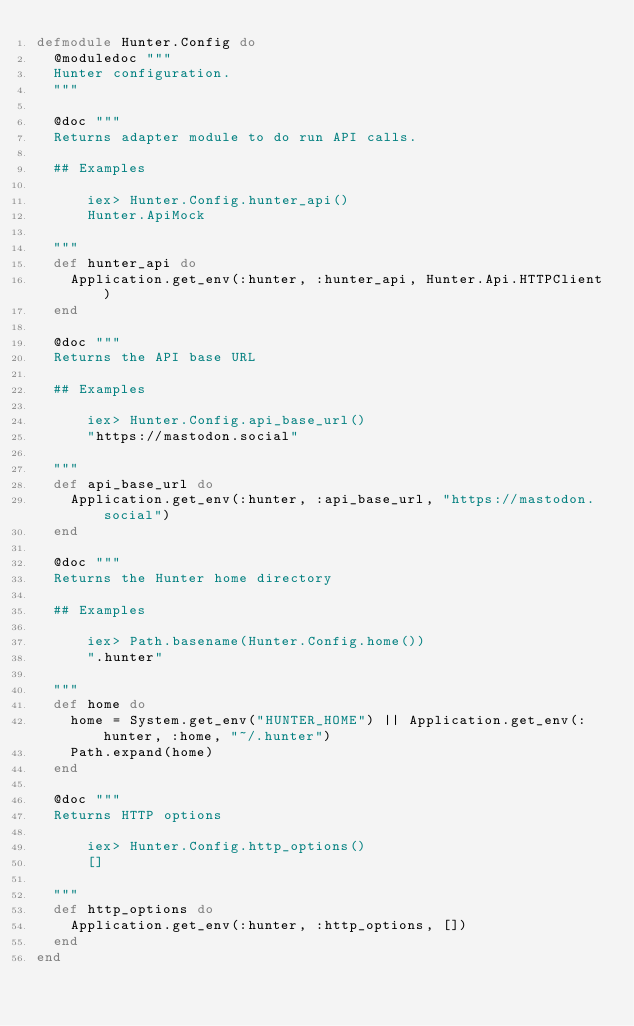<code> <loc_0><loc_0><loc_500><loc_500><_Elixir_>defmodule Hunter.Config do
  @moduledoc """
  Hunter configuration.
  """

  @doc """
  Returns adapter module to do run API calls.

  ## Examples

      iex> Hunter.Config.hunter_api()
      Hunter.ApiMock

  """
  def hunter_api do
    Application.get_env(:hunter, :hunter_api, Hunter.Api.HTTPClient)
  end

  @doc """
  Returns the API base URL

  ## Examples

      iex> Hunter.Config.api_base_url()
      "https://mastodon.social"

  """
  def api_base_url do
    Application.get_env(:hunter, :api_base_url, "https://mastodon.social")
  end

  @doc """
  Returns the Hunter home directory

  ## Examples

      iex> Path.basename(Hunter.Config.home())
      ".hunter"

  """
  def home do
    home = System.get_env("HUNTER_HOME") || Application.get_env(:hunter, :home, "~/.hunter")
    Path.expand(home)
  end

  @doc """
  Returns HTTP options

      iex> Hunter.Config.http_options()
      []

  """
  def http_options do
    Application.get_env(:hunter, :http_options, [])
  end
end
</code> 